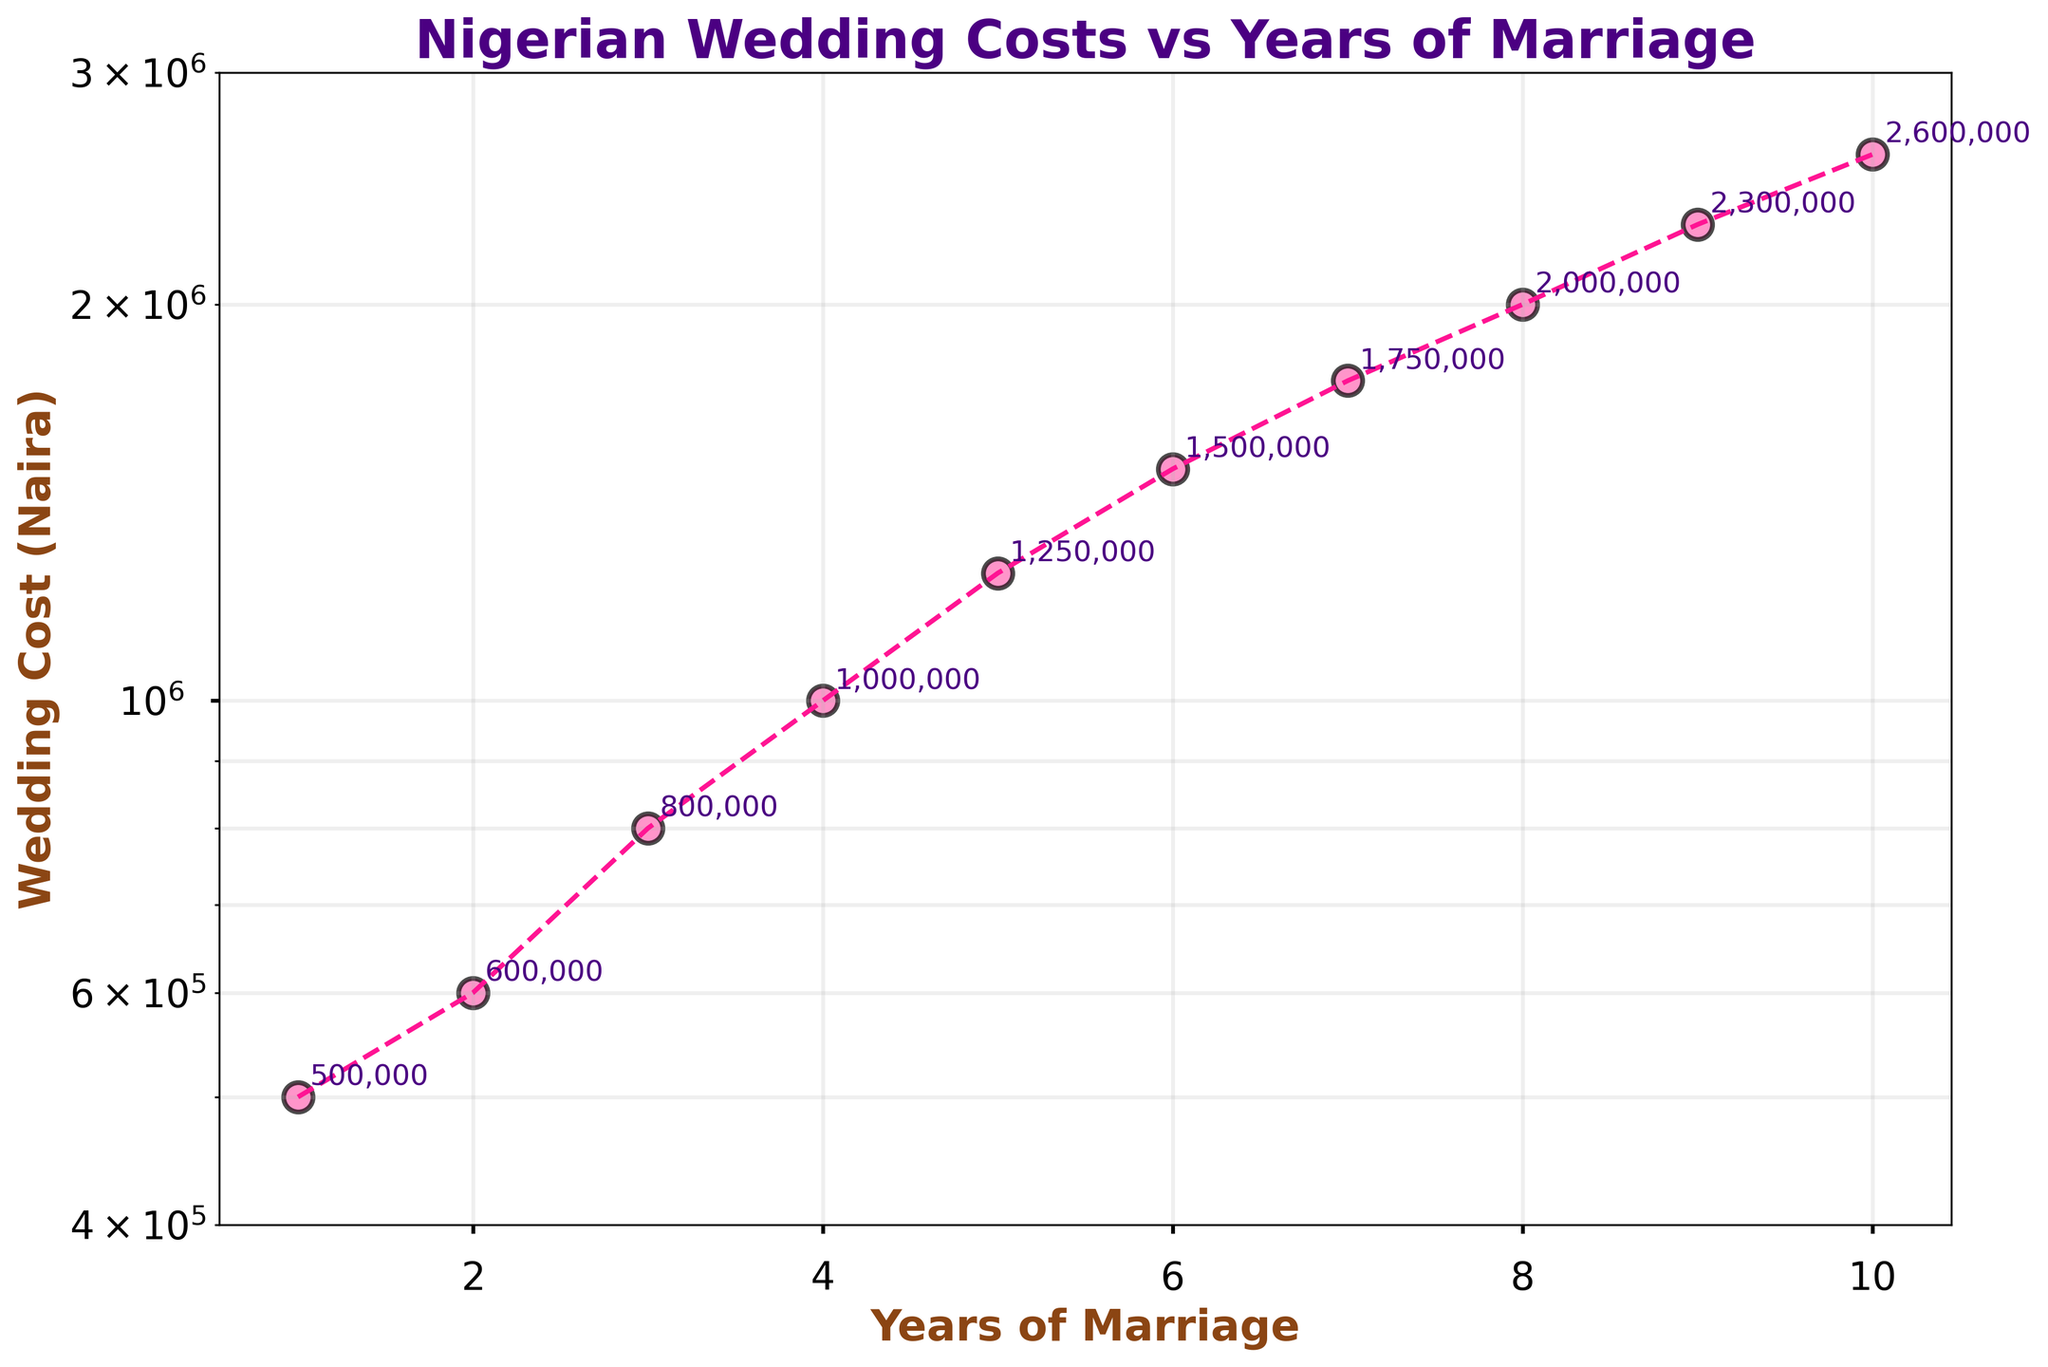What is the title of the plot? The title of the plot is located at the top of the figure. It reads "Nigerian Wedding Costs vs Years of Marriage".
Answer: Nigerian Wedding Costs vs Years of Marriage How many data points are shown in the plot? By counting the number of dots (scatter points) on the plot, you can determine the number of data points, which are 10.
Answer: 10 What is the y-axis label? The label of the y-axis is situated along the vertical axis. It reads "Wedding Cost (Naira)".
Answer: Wedding Cost (Naira) What is the cost of a wedding in the first year of marriage? Locate the scatter point corresponding to 1 on the x-axis and read the y value. The annotated text near the point shows 500,000.
Answer: 500,000 By how much did the wedding cost increase from the first to the fifth year? Find the y-values for 1 year (500,000) and 5 years (1,250,000). Subtract the first cost from the fifth-year cost: 1,250,000 - 500,000 = 750,000.
Answer: 750,000 What is the range of the y-axis? The y-axis range is given by the minimum and maximum limits. From the plot, the y-axis ranges from 400,000 to 3,000,000.
Answer: 400,000 to 3,000,000 How does wedding cost change over the years in general? Observe the trend line connecting the scatter points. It generally shows an increasing trend as the number of years of marriage increases.
Answer: increases Which year shows the highest wedding cost? Locate the year on the x-axis corresponding to the highest point on the y-axis. The highest cost 2,600,000 occurs at 10 years.
Answer: 10 years What is the approximate wedding cost at 7 years of marriage? Find the scatter point corresponding to 7 on the x-axis and read the y value. The annotated value is approximately 1,750,000.
Answer: 1,750,000 What is the difference in wedding cost between the 4th and the 8th year of marriage? Identify the y-values for 4 years (1,000,000) and 8 years (2,000,000). Subtract the cost at 4 years from the cost at 8 years: 2,000,000 - 1,000,000 = 1,000,000.
Answer: 1,000,000 